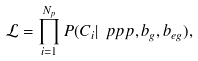Convert formula to latex. <formula><loc_0><loc_0><loc_500><loc_500>\mathcal { L } = \prod _ { i = 1 } ^ { N _ { p } } P ( C _ { i } | \ p p p , b _ { g } , b _ { e g } ) ,</formula> 